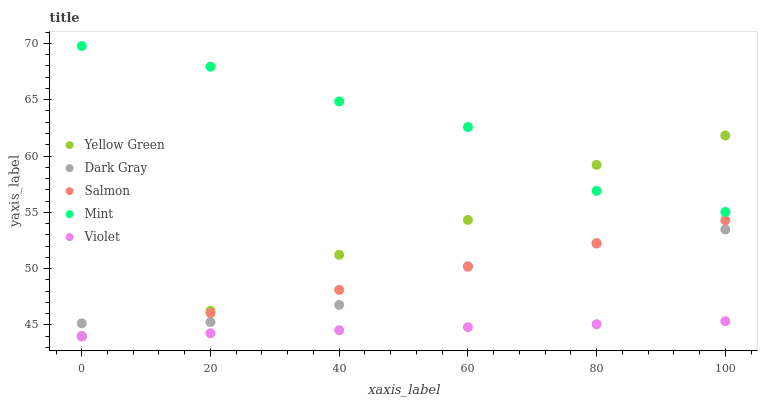Does Violet have the minimum area under the curve?
Answer yes or no. Yes. Does Mint have the maximum area under the curve?
Answer yes or no. Yes. Does Salmon have the minimum area under the curve?
Answer yes or no. No. Does Salmon have the maximum area under the curve?
Answer yes or no. No. Is Salmon the smoothest?
Answer yes or no. Yes. Is Mint the roughest?
Answer yes or no. Yes. Is Mint the smoothest?
Answer yes or no. No. Is Salmon the roughest?
Answer yes or no. No. Does Salmon have the lowest value?
Answer yes or no. Yes. Does Mint have the lowest value?
Answer yes or no. No. Does Mint have the highest value?
Answer yes or no. Yes. Does Salmon have the highest value?
Answer yes or no. No. Is Violet less than Mint?
Answer yes or no. Yes. Is Mint greater than Salmon?
Answer yes or no. Yes. Does Yellow Green intersect Mint?
Answer yes or no. Yes. Is Yellow Green less than Mint?
Answer yes or no. No. Is Yellow Green greater than Mint?
Answer yes or no. No. Does Violet intersect Mint?
Answer yes or no. No. 